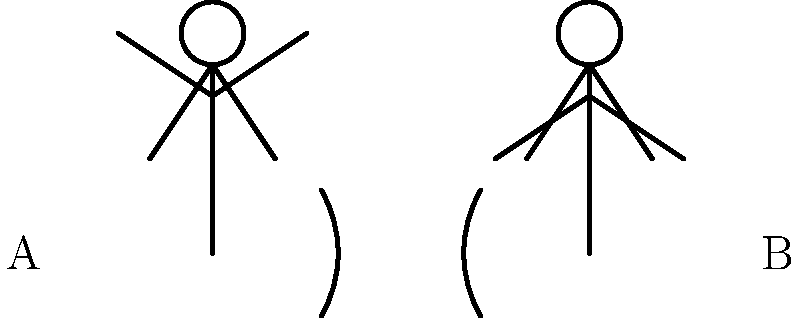In this classic K-drama scene, which stick figure is likely exhibiting the "aegyo" (cute) behavior often seen in romantic moments? To determine which stick figure is exhibiting "aegyo" behavior, we need to analyze the body language of both figures:

1. Figure A (left):
   - Arms raised above the head
   - Body facing forward
   - This posture suggests an open, energetic, and possibly playful stance

2. Figure B (right):
   - Arms by the sides
   - Body turned away
   - This posture suggests a more closed-off or neutral stance

In K-dramas, "aegyo" often involves exaggerated cute gestures, such as raising arms, making heart shapes with hands, or striking playful poses. These actions are meant to appear endearing and charming to the other person.

Given this context, Figure A's raised arms and open posture align more closely with typical "aegyo" behavior seen in K-dramas. This pose could be interpreted as a cute or playful gesture to attract attention or express affection.

Figure B's more neutral stance doesn't exhibit the typical exaggerated movements associated with "aegyo".
Answer: Figure A 